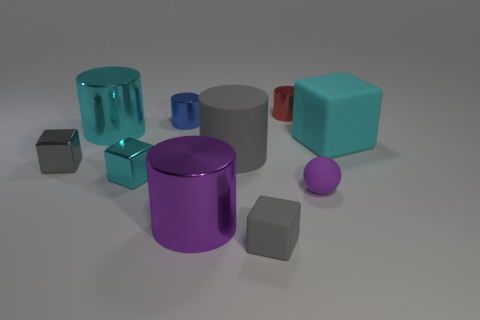What is the color of the small ball?
Your answer should be very brief. Purple. What number of metallic objects have the same shape as the big gray rubber thing?
Provide a short and direct response. 4. There is a rubber block that is the same size as the gray metal thing; what is its color?
Make the answer very short. Gray. Is there a large gray metal cylinder?
Ensure brevity in your answer.  No. What shape is the cyan object that is to the right of the small purple sphere?
Give a very brief answer. Cube. What number of things are both in front of the purple metallic thing and to the left of the big cyan shiny object?
Ensure brevity in your answer.  0. Is there a small gray sphere made of the same material as the blue object?
Provide a succinct answer. No. The thing that is the same color as the small sphere is what size?
Offer a very short reply. Large. How many blocks are either big purple rubber objects or small cyan metal things?
Your answer should be compact. 1. The gray shiny cube has what size?
Your response must be concise. Small. 